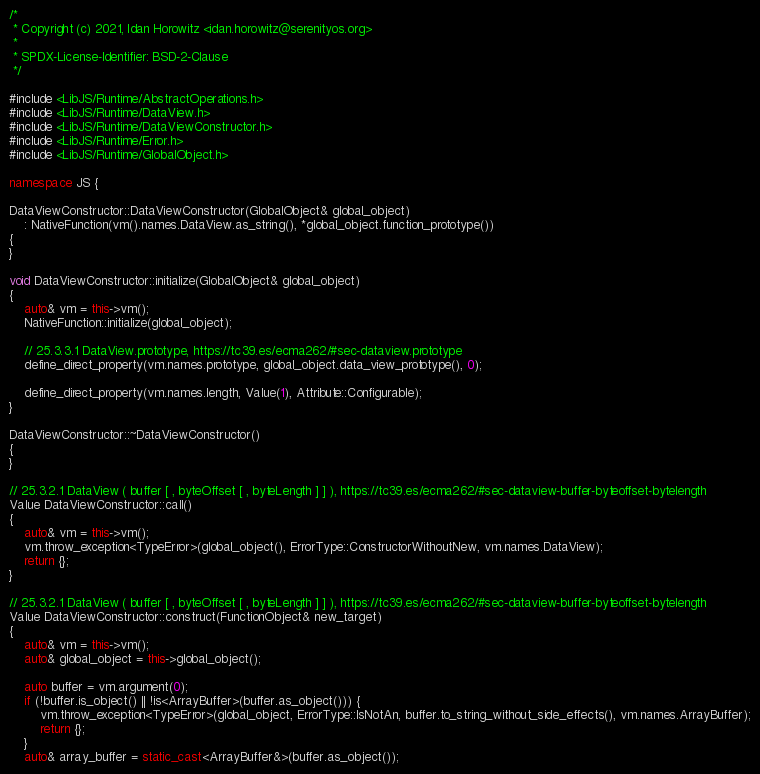<code> <loc_0><loc_0><loc_500><loc_500><_C++_>/*
 * Copyright (c) 2021, Idan Horowitz <idan.horowitz@serenityos.org>
 *
 * SPDX-License-Identifier: BSD-2-Clause
 */

#include <LibJS/Runtime/AbstractOperations.h>
#include <LibJS/Runtime/DataView.h>
#include <LibJS/Runtime/DataViewConstructor.h>
#include <LibJS/Runtime/Error.h>
#include <LibJS/Runtime/GlobalObject.h>

namespace JS {

DataViewConstructor::DataViewConstructor(GlobalObject& global_object)
    : NativeFunction(vm().names.DataView.as_string(), *global_object.function_prototype())
{
}

void DataViewConstructor::initialize(GlobalObject& global_object)
{
    auto& vm = this->vm();
    NativeFunction::initialize(global_object);

    // 25.3.3.1 DataView.prototype, https://tc39.es/ecma262/#sec-dataview.prototype
    define_direct_property(vm.names.prototype, global_object.data_view_prototype(), 0);

    define_direct_property(vm.names.length, Value(1), Attribute::Configurable);
}

DataViewConstructor::~DataViewConstructor()
{
}

// 25.3.2.1 DataView ( buffer [ , byteOffset [ , byteLength ] ] ), https://tc39.es/ecma262/#sec-dataview-buffer-byteoffset-bytelength
Value DataViewConstructor::call()
{
    auto& vm = this->vm();
    vm.throw_exception<TypeError>(global_object(), ErrorType::ConstructorWithoutNew, vm.names.DataView);
    return {};
}

// 25.3.2.1 DataView ( buffer [ , byteOffset [ , byteLength ] ] ), https://tc39.es/ecma262/#sec-dataview-buffer-byteoffset-bytelength
Value DataViewConstructor::construct(FunctionObject& new_target)
{
    auto& vm = this->vm();
    auto& global_object = this->global_object();

    auto buffer = vm.argument(0);
    if (!buffer.is_object() || !is<ArrayBuffer>(buffer.as_object())) {
        vm.throw_exception<TypeError>(global_object, ErrorType::IsNotAn, buffer.to_string_without_side_effects(), vm.names.ArrayBuffer);
        return {};
    }
    auto& array_buffer = static_cast<ArrayBuffer&>(buffer.as_object());
</code> 